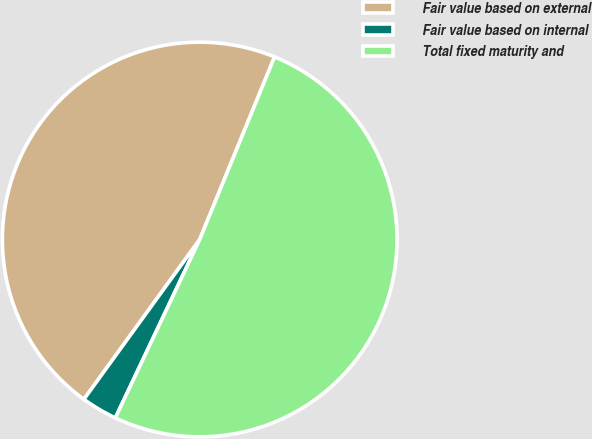<chart> <loc_0><loc_0><loc_500><loc_500><pie_chart><fcel>Fair value based on external<fcel>Fair value based on internal<fcel>Total fixed maturity and<nl><fcel>46.21%<fcel>2.95%<fcel>50.84%<nl></chart> 